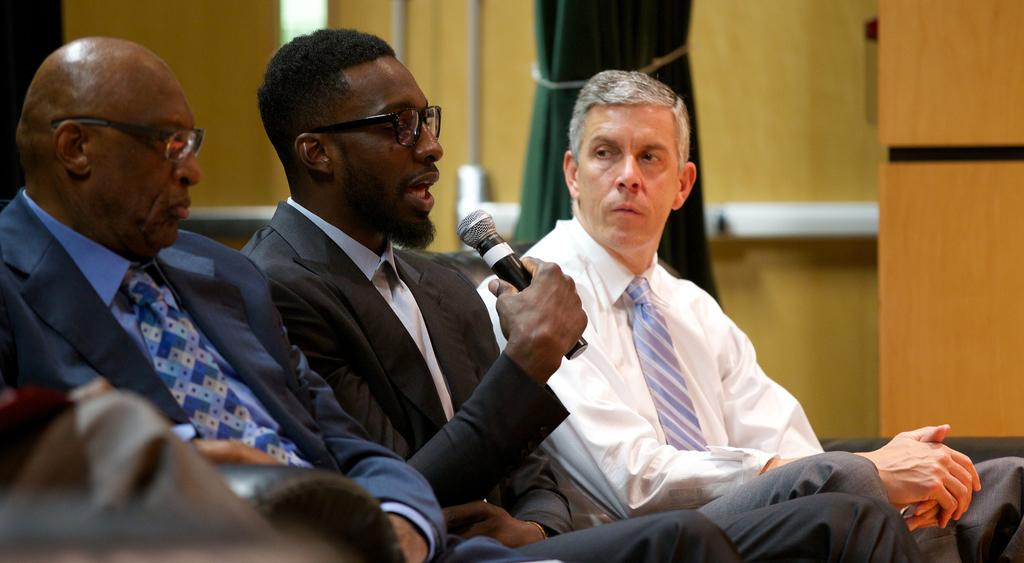How many people are in the foreground of the image? There are three persons in the foreground of the image. What is one person holding in their hand? One person is holding a microphone in their hand. What can be seen in the background of the image? There is a wall and a curtain in the background of the image. Where was the image taken? The image was taken in a hall. What time of day is it in the image? The provided facts do not mention the time of day. How many chickens are present in the image? There are no chickens present in the image. 